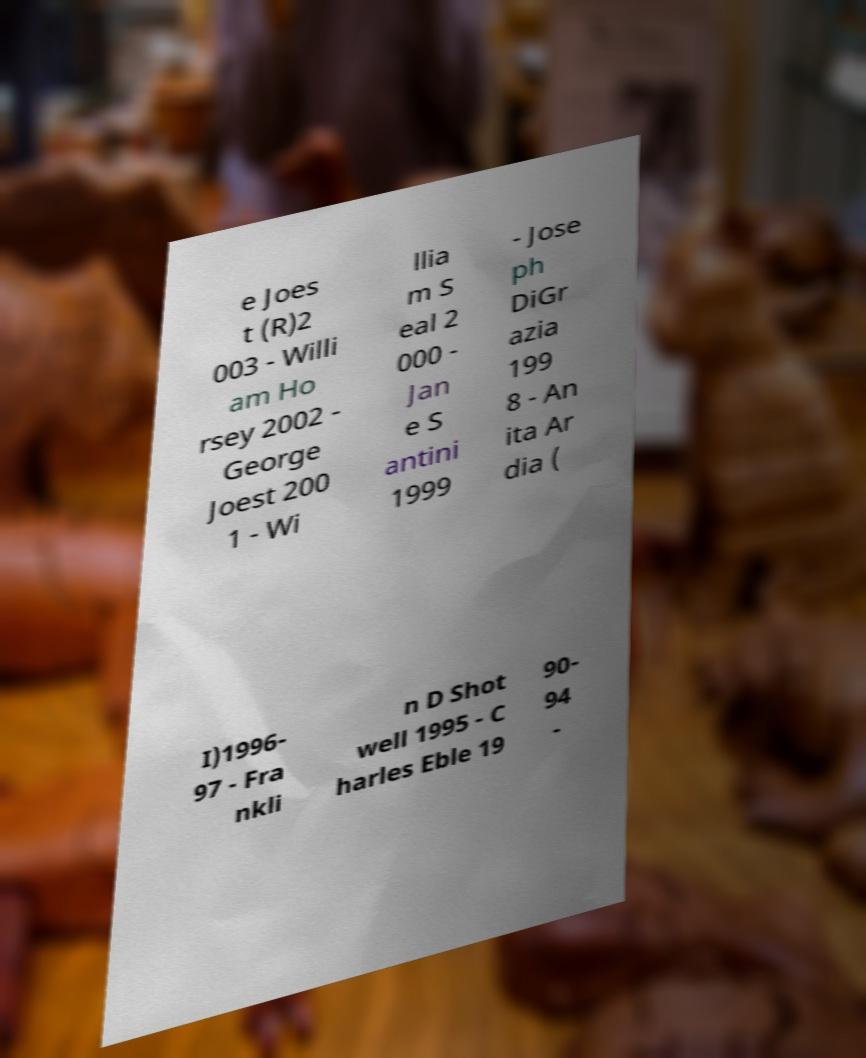Could you assist in decoding the text presented in this image and type it out clearly? e Joes t (R)2 003 - Willi am Ho rsey 2002 - George Joest 200 1 - Wi llia m S eal 2 000 - Jan e S antini 1999 - Jose ph DiGr azia 199 8 - An ita Ar dia ( I)1996- 97 - Fra nkli n D Shot well 1995 - C harles Eble 19 90- 94 - 